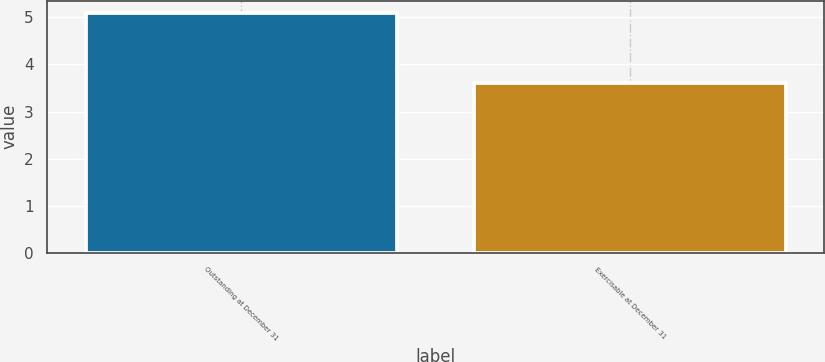Convert chart to OTSL. <chart><loc_0><loc_0><loc_500><loc_500><bar_chart><fcel>Outstanding at December 31<fcel>Exercisable at December 31<nl><fcel>5.1<fcel>3.6<nl></chart> 